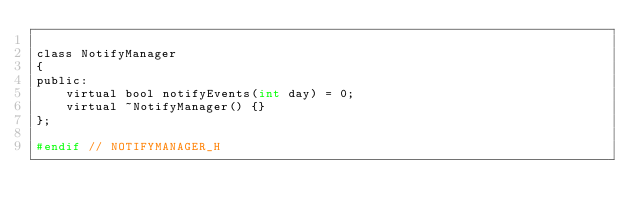Convert code to text. <code><loc_0><loc_0><loc_500><loc_500><_C_>
class NotifyManager
{
public:
    virtual bool notifyEvents(int day) = 0;
    virtual ~NotifyManager() {}
};

#endif // NOTIFYMANAGER_H
</code> 